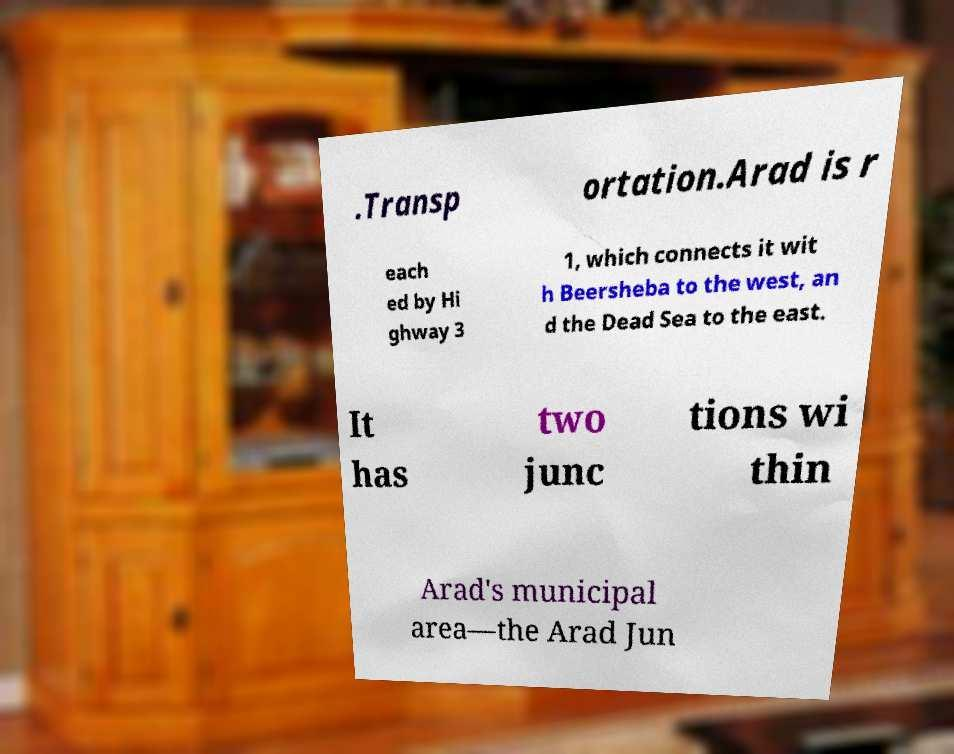There's text embedded in this image that I need extracted. Can you transcribe it verbatim? .Transp ortation.Arad is r each ed by Hi ghway 3 1, which connects it wit h Beersheba to the west, an d the Dead Sea to the east. It has two junc tions wi thin Arad's municipal area—the Arad Jun 